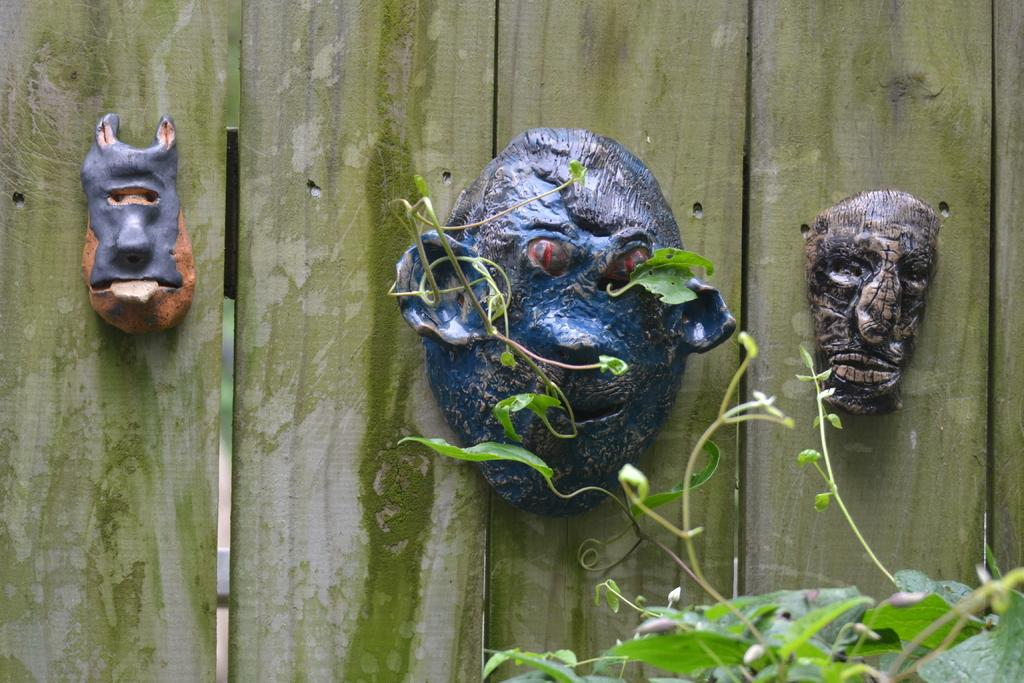What objects are present in the image? There are masks on wooden planks in the image. What type of material are the planks made of? The wooden planks are made of wood. Is there any vegetation visible in the image? Yes, there is a plant in the image. How many rings are being worn by the laborer in the image? There is no laborer present in the image, and therefore no rings can be observed. 